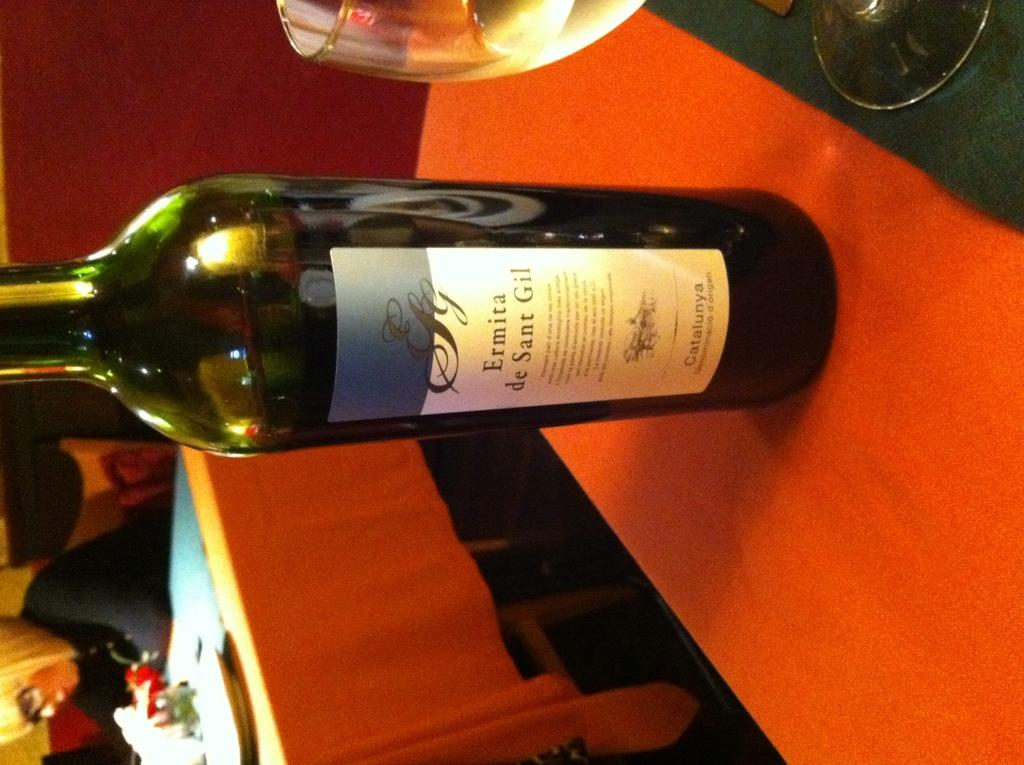<image>
Summarize the visual content of the image. A bottle of Ermita sits on a wooden table. 